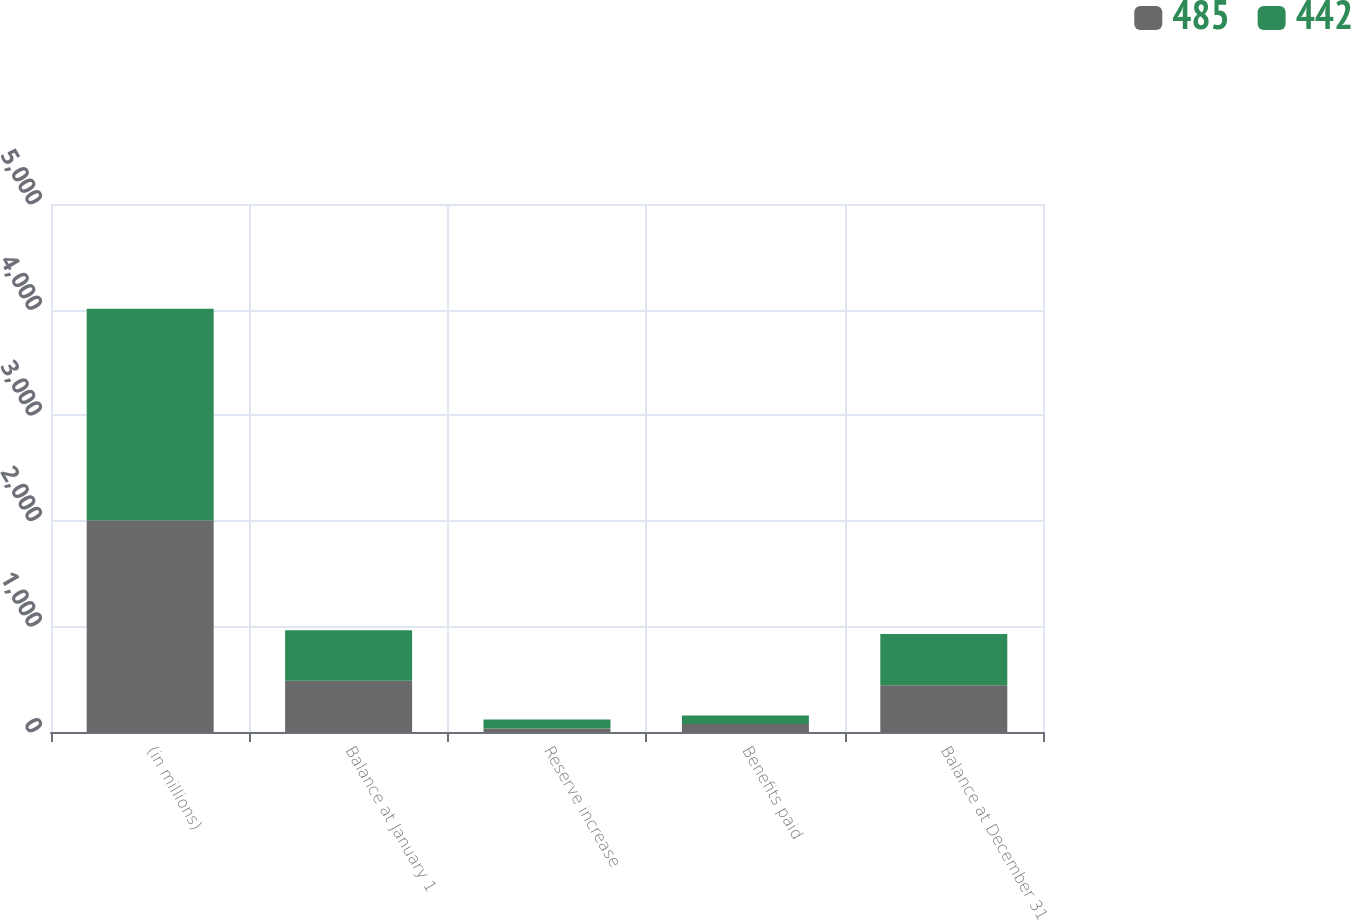<chart> <loc_0><loc_0><loc_500><loc_500><stacked_bar_chart><ecel><fcel>(in millions)<fcel>Balance at January 1<fcel>Reserve increase<fcel>Benefits paid<fcel>Balance at December 31<nl><fcel>485<fcel>2005<fcel>485<fcel>33<fcel>76<fcel>442<nl><fcel>442<fcel>2004<fcel>479<fcel>86<fcel>80<fcel>485<nl></chart> 